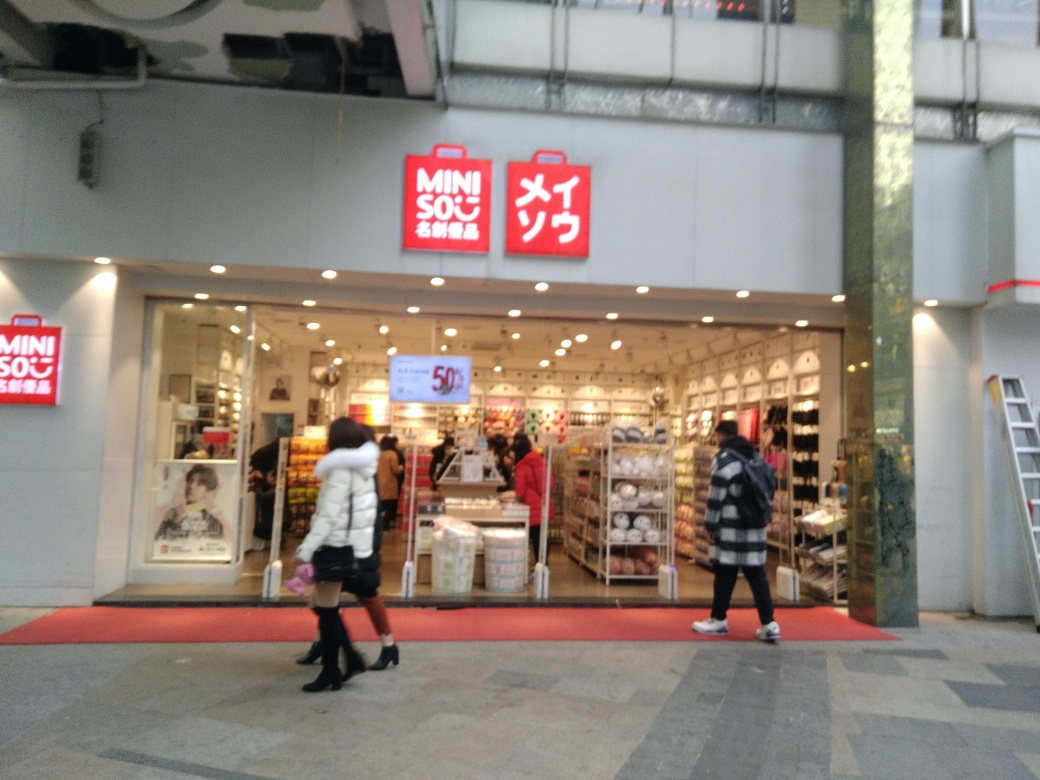Is there any indication of a sale or special offer visible in the storefront? Yes, there is a noticeable promotion indicated on the storefront. A sign with '-50%' suggests a significant discount, likely a part of a sale or special offer to attract customers. This kind of promotion is often used to entice shoppers to enter the store and potentially increase sales volume by offering products at reduced prices. 